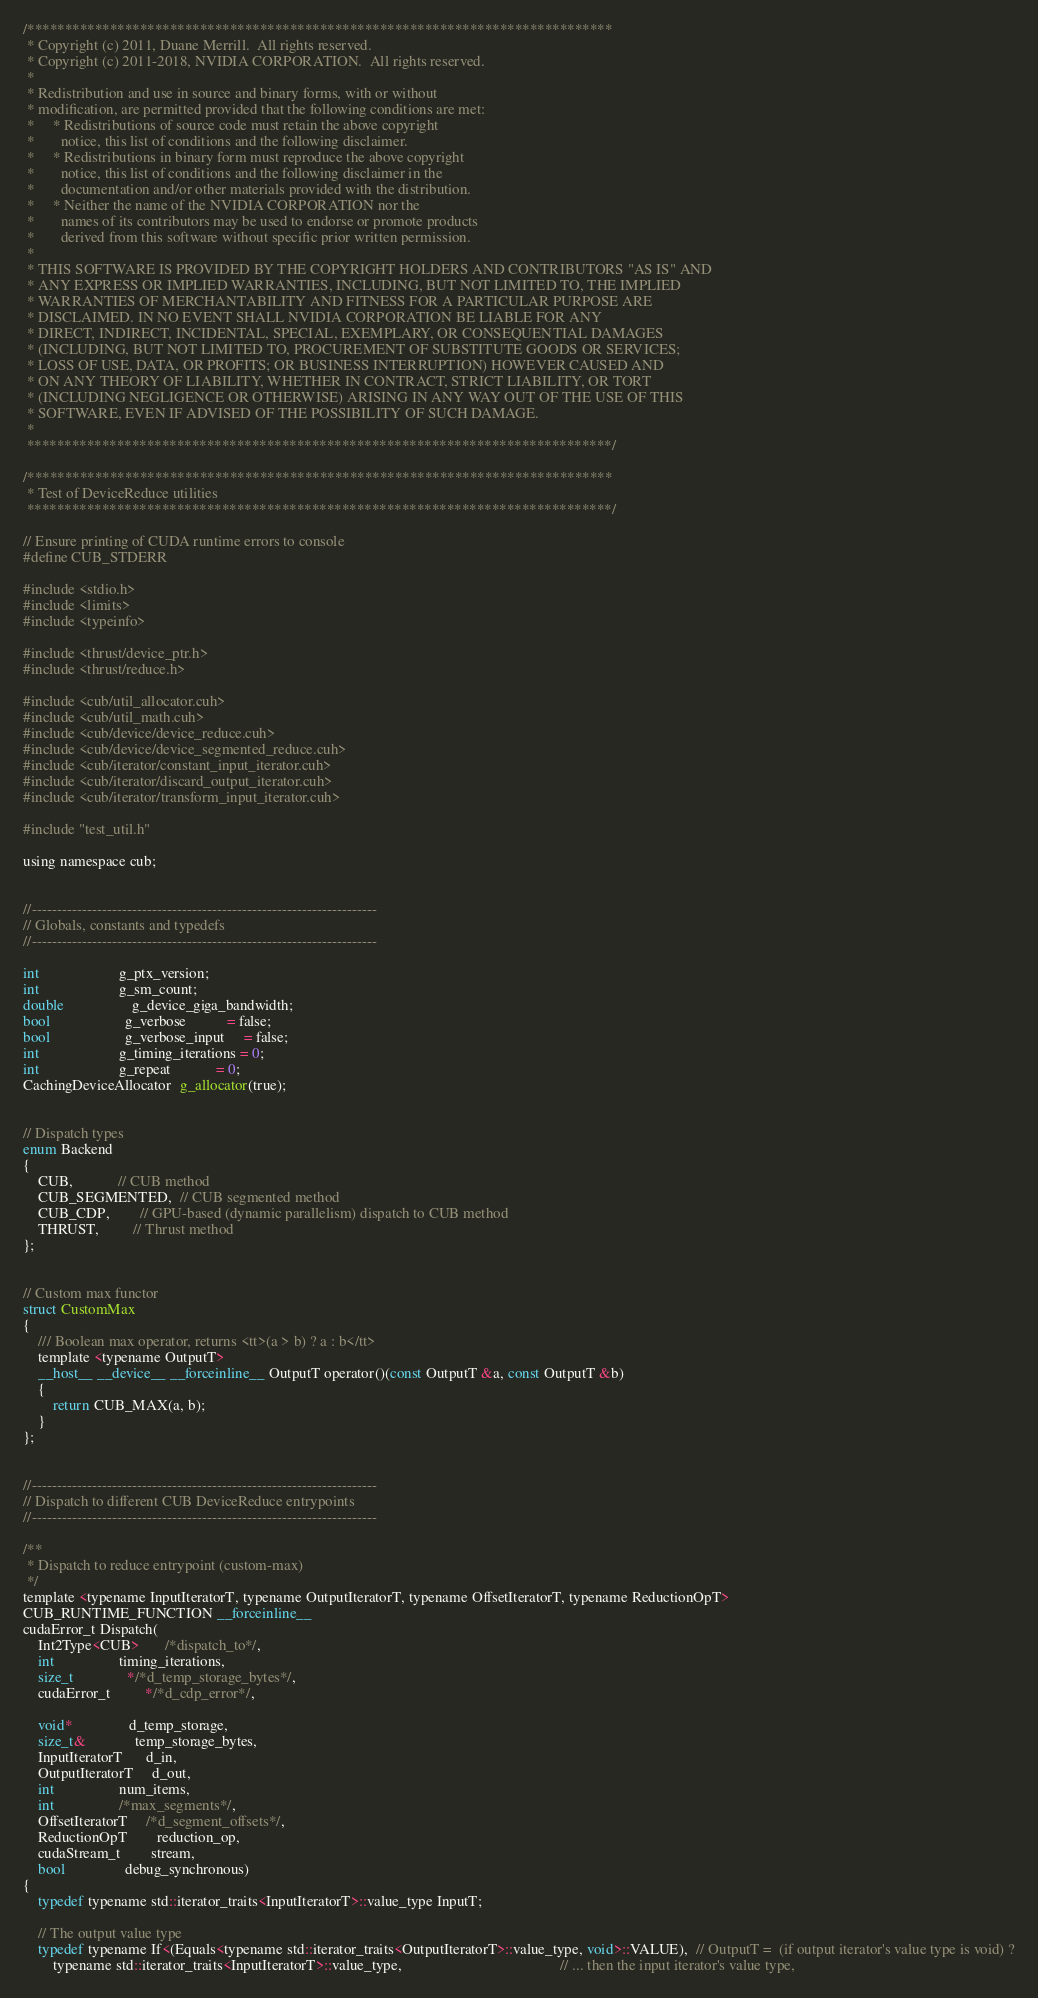<code> <loc_0><loc_0><loc_500><loc_500><_Cuda_>/******************************************************************************
 * Copyright (c) 2011, Duane Merrill.  All rights reserved.
 * Copyright (c) 2011-2018, NVIDIA CORPORATION.  All rights reserved.
 *
 * Redistribution and use in source and binary forms, with or without
 * modification, are permitted provided that the following conditions are met:
 *     * Redistributions of source code must retain the above copyright
 *       notice, this list of conditions and the following disclaimer.
 *     * Redistributions in binary form must reproduce the above copyright
 *       notice, this list of conditions and the following disclaimer in the
 *       documentation and/or other materials provided with the distribution.
 *     * Neither the name of the NVIDIA CORPORATION nor the
 *       names of its contributors may be used to endorse or promote products
 *       derived from this software without specific prior written permission.
 *
 * THIS SOFTWARE IS PROVIDED BY THE COPYRIGHT HOLDERS AND CONTRIBUTORS "AS IS" AND
 * ANY EXPRESS OR IMPLIED WARRANTIES, INCLUDING, BUT NOT LIMITED TO, THE IMPLIED
 * WARRANTIES OF MERCHANTABILITY AND FITNESS FOR A PARTICULAR PURPOSE ARE
 * DISCLAIMED. IN NO EVENT SHALL NVIDIA CORPORATION BE LIABLE FOR ANY
 * DIRECT, INDIRECT, INCIDENTAL, SPECIAL, EXEMPLARY, OR CONSEQUENTIAL DAMAGES
 * (INCLUDING, BUT NOT LIMITED TO, PROCUREMENT OF SUBSTITUTE GOODS OR SERVICES;
 * LOSS OF USE, DATA, OR PROFITS; OR BUSINESS INTERRUPTION) HOWEVER CAUSED AND
 * ON ANY THEORY OF LIABILITY, WHETHER IN CONTRACT, STRICT LIABILITY, OR TORT
 * (INCLUDING NEGLIGENCE OR OTHERWISE) ARISING IN ANY WAY OUT OF THE USE OF THIS
 * SOFTWARE, EVEN IF ADVISED OF THE POSSIBILITY OF SUCH DAMAGE.
 *
 ******************************************************************************/

/******************************************************************************
 * Test of DeviceReduce utilities
 ******************************************************************************/

// Ensure printing of CUDA runtime errors to console
#define CUB_STDERR

#include <stdio.h>
#include <limits>
#include <typeinfo>

#include <thrust/device_ptr.h>
#include <thrust/reduce.h>

#include <cub/util_allocator.cuh>
#include <cub/util_math.cuh>
#include <cub/device/device_reduce.cuh>
#include <cub/device/device_segmented_reduce.cuh>
#include <cub/iterator/constant_input_iterator.cuh>
#include <cub/iterator/discard_output_iterator.cuh>
#include <cub/iterator/transform_input_iterator.cuh>

#include "test_util.h"

using namespace cub;


//---------------------------------------------------------------------
// Globals, constants and typedefs
//---------------------------------------------------------------------

int                     g_ptx_version;
int                     g_sm_count;
double                  g_device_giga_bandwidth;
bool                    g_verbose           = false;
bool                    g_verbose_input     = false;
int                     g_timing_iterations = 0;
int                     g_repeat            = 0;
CachingDeviceAllocator  g_allocator(true);


// Dispatch types
enum Backend
{
    CUB,            // CUB method
    CUB_SEGMENTED,  // CUB segmented method
    CUB_CDP,        // GPU-based (dynamic parallelism) dispatch to CUB method
    THRUST,         // Thrust method
};


// Custom max functor
struct CustomMax
{
    /// Boolean max operator, returns <tt>(a > b) ? a : b</tt>
    template <typename OutputT>
    __host__ __device__ __forceinline__ OutputT operator()(const OutputT &a, const OutputT &b)
    {
        return CUB_MAX(a, b);
    }
};


//---------------------------------------------------------------------
// Dispatch to different CUB DeviceReduce entrypoints
//---------------------------------------------------------------------

/**
 * Dispatch to reduce entrypoint (custom-max)
 */
template <typename InputIteratorT, typename OutputIteratorT, typename OffsetIteratorT, typename ReductionOpT>
CUB_RUNTIME_FUNCTION __forceinline__
cudaError_t Dispatch(
    Int2Type<CUB>       /*dispatch_to*/,
    int                 timing_iterations,
    size_t              */*d_temp_storage_bytes*/,
    cudaError_t         */*d_cdp_error*/,

    void*               d_temp_storage,
    size_t&             temp_storage_bytes,
    InputIteratorT      d_in,
    OutputIteratorT     d_out,
    int                 num_items,
    int                 /*max_segments*/,
    OffsetIteratorT     /*d_segment_offsets*/,
    ReductionOpT        reduction_op,
    cudaStream_t        stream,
    bool                debug_synchronous)
{
    typedef typename std::iterator_traits<InputIteratorT>::value_type InputT;

    // The output value type
    typedef typename If<(Equals<typename std::iterator_traits<OutputIteratorT>::value_type, void>::VALUE),  // OutputT =  (if output iterator's value type is void) ?
        typename std::iterator_traits<InputIteratorT>::value_type,                                          // ... then the input iterator's value type,</code> 